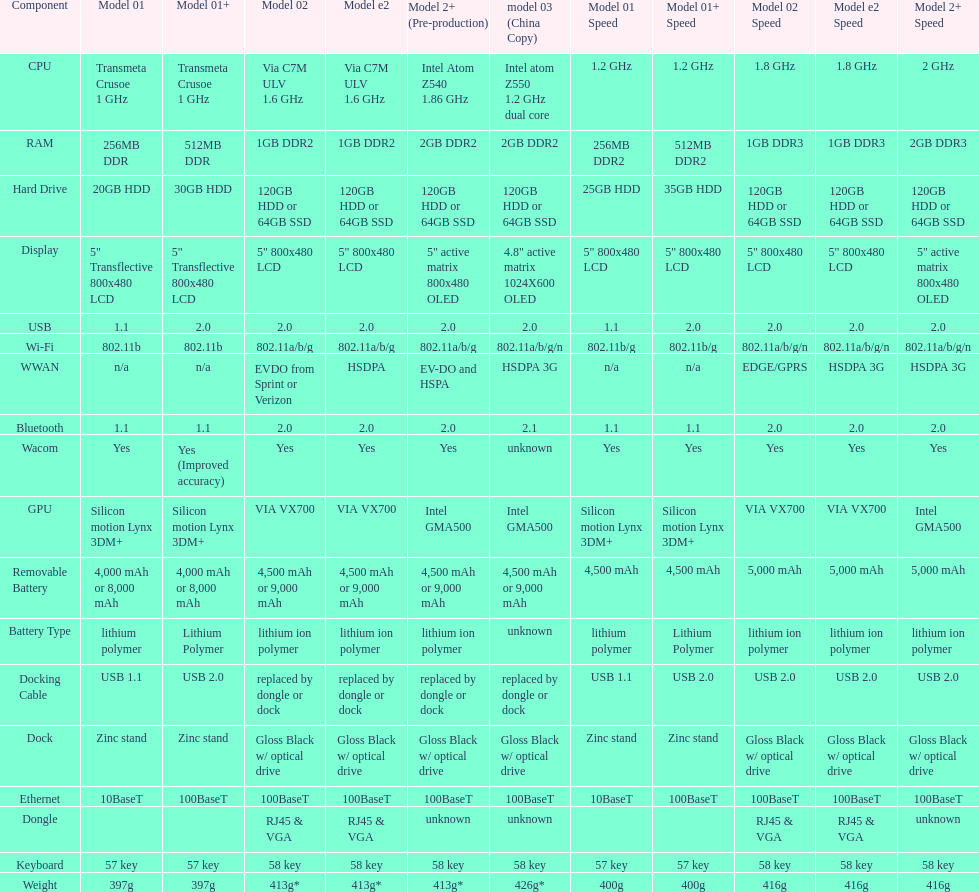What is the next highest hard drive available after the 30gb model? 64GB SSD. 